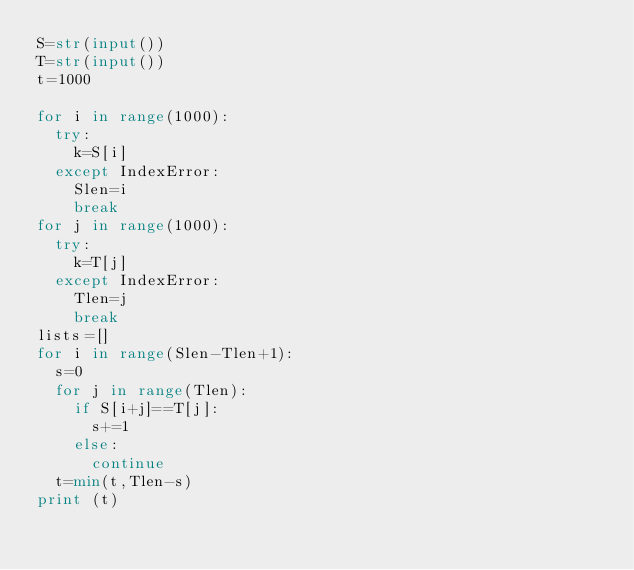<code> <loc_0><loc_0><loc_500><loc_500><_Python_>S=str(input())
T=str(input())
t=1000

for i in range(1000):
  try:
    k=S[i]
  except IndexError:
    Slen=i
    break
for j in range(1000):
  try:
    k=T[j]
  except IndexError:
    Tlen=j
    break
lists=[]
for i in range(Slen-Tlen+1):
  s=0
  for j in range(Tlen):
    if S[i+j]==T[j]:
      s+=1
    else:
      continue
  t=min(t,Tlen-s)
print (t)</code> 